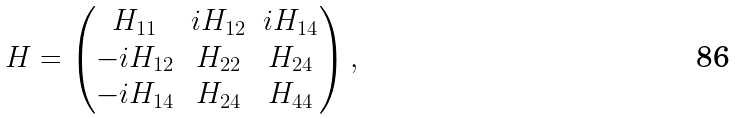<formula> <loc_0><loc_0><loc_500><loc_500>H = \begin{pmatrix} H _ { 1 1 } & i H _ { 1 2 } & i H _ { 1 4 } \\ - i H _ { 1 2 } & H _ { 2 2 } & H _ { 2 4 } \\ - i H _ { 1 4 } & H _ { 2 4 } & H _ { 4 4 } \end{pmatrix} ,</formula> 